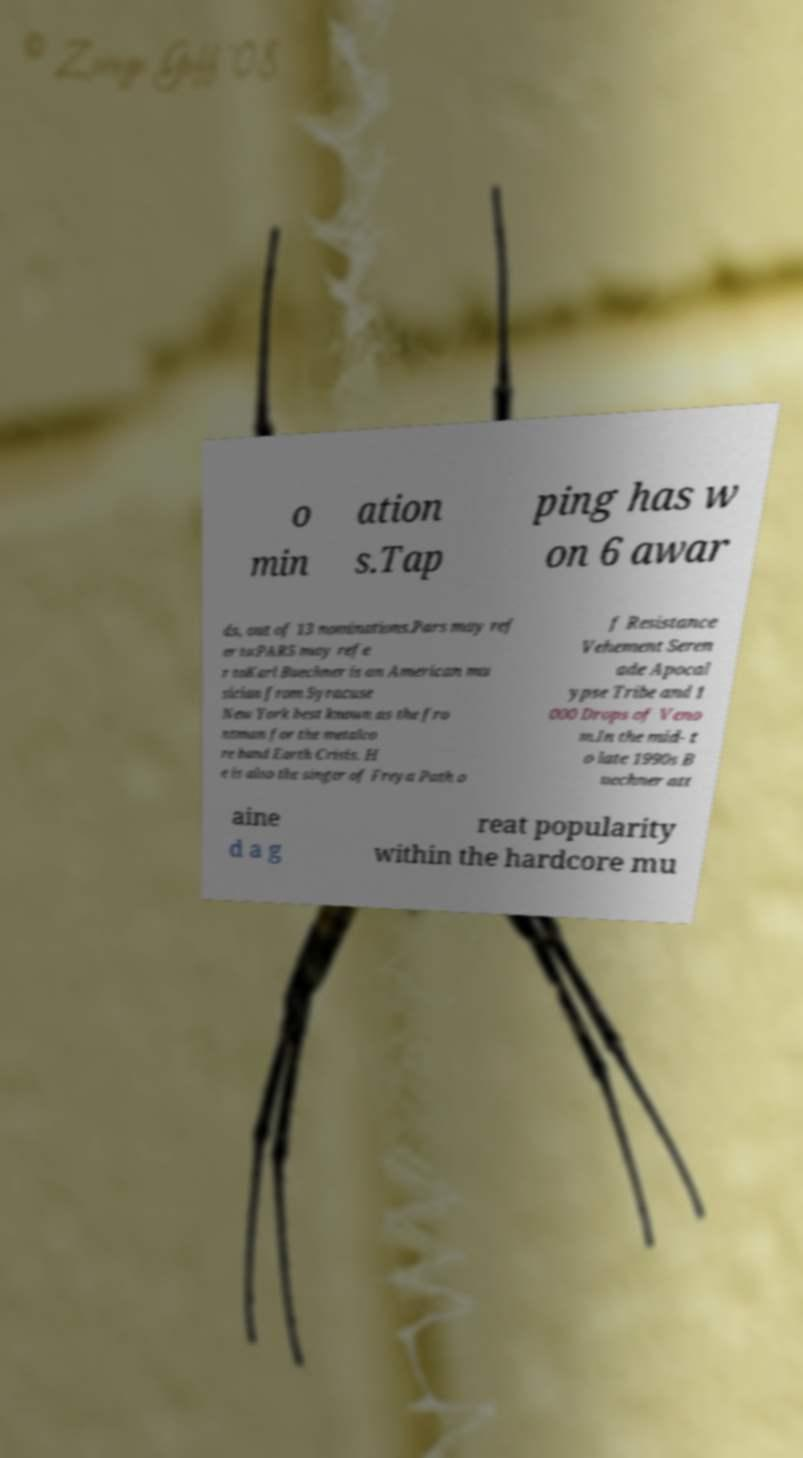There's text embedded in this image that I need extracted. Can you transcribe it verbatim? o min ation s.Tap ping has w on 6 awar ds, out of 13 nominations.Pars may ref er to:PARS may refe r toKarl Buechner is an American mu sician from Syracuse New York best known as the fro ntman for the metalco re band Earth Crisis. H e is also the singer of Freya Path o f Resistance Vehement Seren ade Apocal ypse Tribe and 1 000 Drops of Veno m.In the mid- t o late 1990s B uechner att aine d a g reat popularity within the hardcore mu 